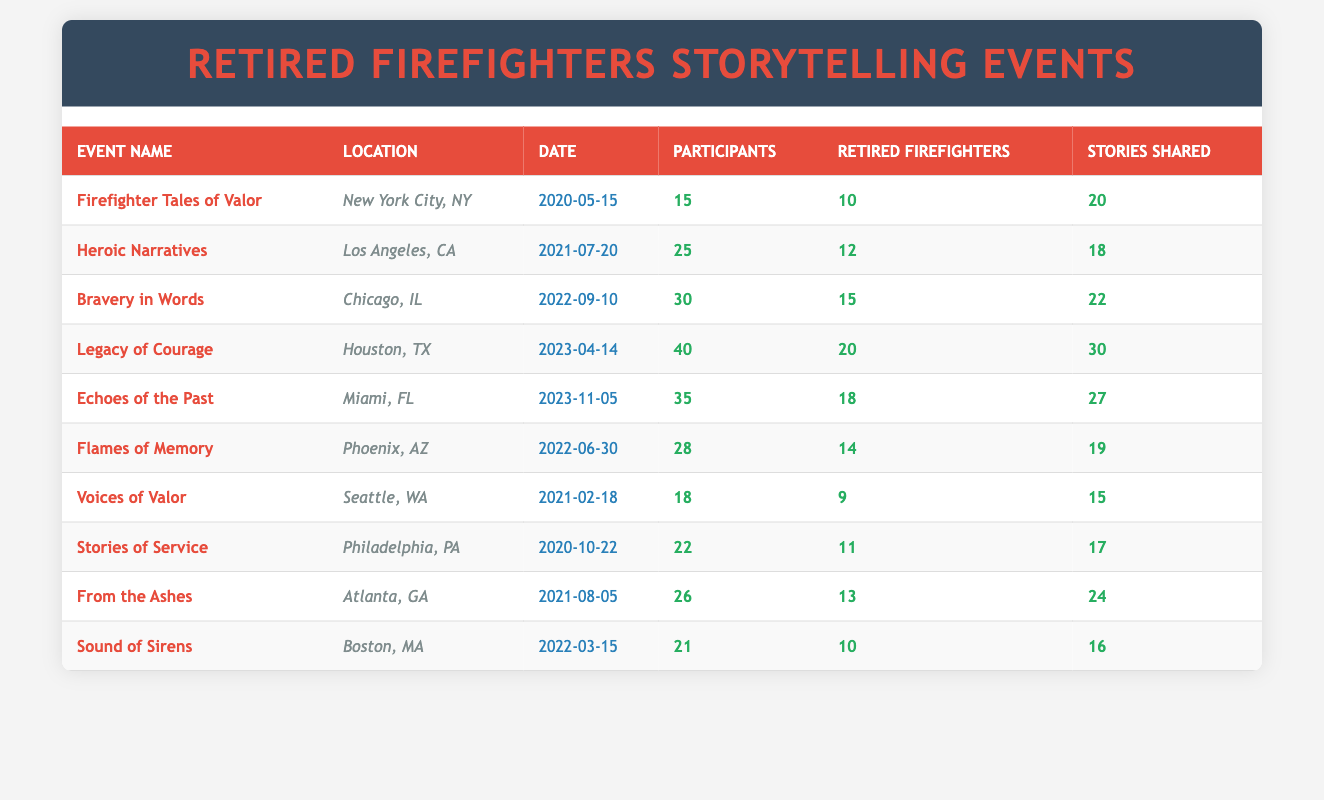What is the total number of participants at the "Legacies of Courage" event? The "Legacies of Courage" event had 40 participants listed in the table under the "Participants" column.
Answer: 40 How many retired firefighters participated in the event "From the Ashes" held in Atlanta? The event "From the Ashes" in Atlanta had 13 retired firefighters, as indicated in the corresponding column.
Answer: 13 What is the location of the event with the highest number of stories shared? The event with the highest number of stories shared is "Legacy of Courage," which had 30 stories shared, and it took place in Houston, TX.
Answer: Houston, TX How many total retired firefighters participated across all events in 2023? In 2023, there were two events: "Legacy of Courage" with 20 retired firefighters and "Echoes of the Past" with 18, so the total is 20 + 18 = 38.
Answer: 38 Was there an event with more retired firefighters than active participants? Yes, the "Firefighter Tales of Valor" event had 10 retired firefighters and only 15 total participants, which is more than the number of retired firefighters.
Answer: Yes What is the average number of stories shared per retired firefighter across all events? First, sum the total number of stories shared from all events: 20 + 18 + 22 + 30 + 27 + 19 + 15 + 17 + 24 + 16 =  218 stories. Next, calculate the total retired firefighters: 10 + 12 + 15 + 20 + 18 + 14 + 9 + 11 + 13 + 10 =  142. Finally, divide total stories by total retired firefighters: 218 / 142 ≈ 1.53 stories per retired firefighter.
Answer: 1.53 Which event had the lowest participation of retired firefighters? The event with the lowest participation of retired firefighters is "Voices of Valor," which had only 9 retired firefighters.
Answer: 9 How many retired firefighters participated in events held before 2022? The events held before 2022 are "Firefighter Tales of Valor," "Stories of Service," "Voices of Valor," and "Heroic Narratives." The corresponding retired firefighters are 10, 11, 9, and 12, respectively, summing these gives: 10 + 11 + 9 + 12 = 42 retired firefighters.
Answer: 42 